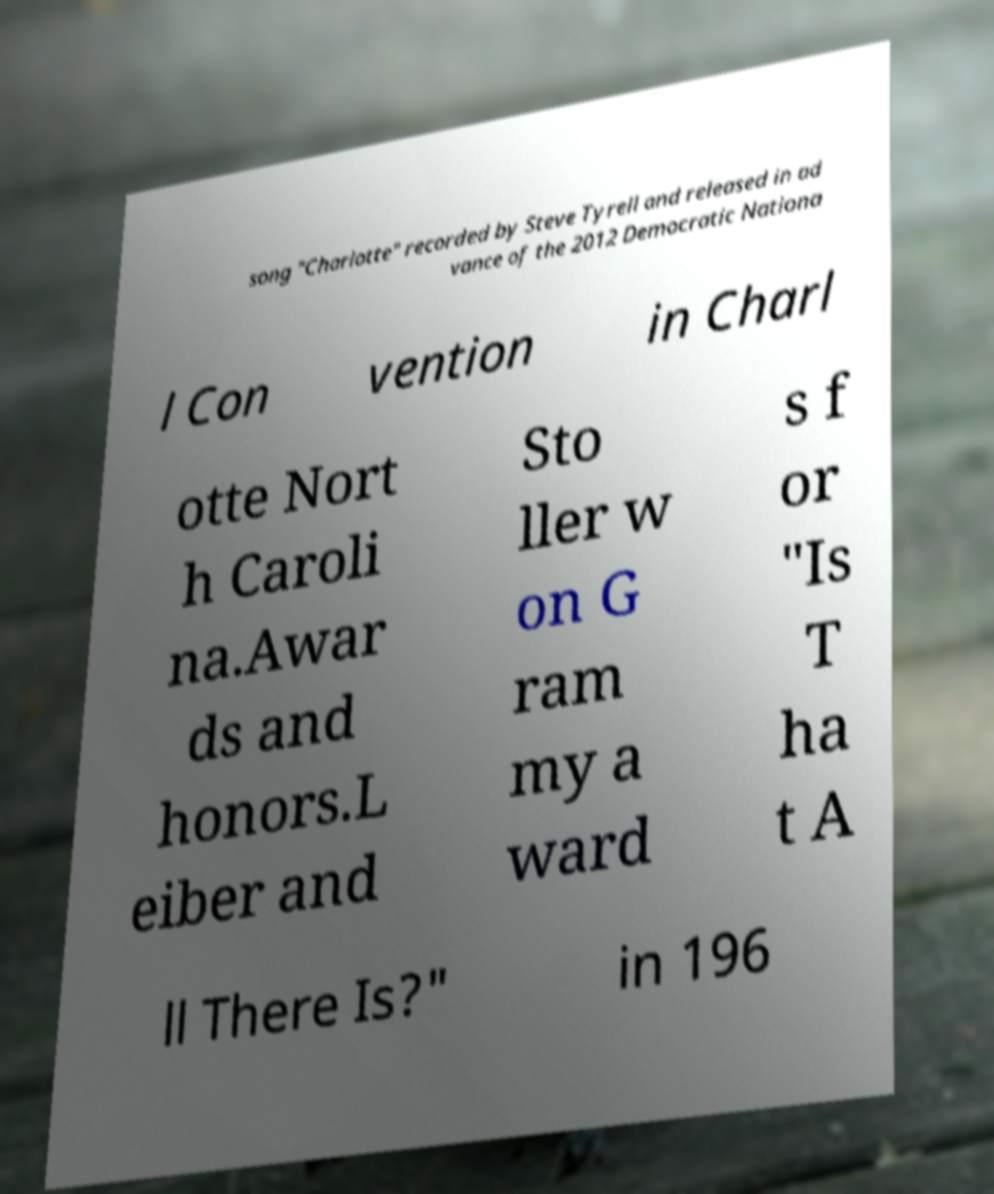Please identify and transcribe the text found in this image. song "Charlotte" recorded by Steve Tyrell and released in ad vance of the 2012 Democratic Nationa l Con vention in Charl otte Nort h Caroli na.Awar ds and honors.L eiber and Sto ller w on G ram my a ward s f or "Is T ha t A ll There Is?" in 196 